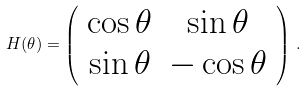Convert formula to latex. <formula><loc_0><loc_0><loc_500><loc_500>H ( \theta ) = \left ( \begin{array} { c c } \cos \theta & \sin \theta \\ \sin \theta & - \cos \theta \end{array} \right ) \, .</formula> 